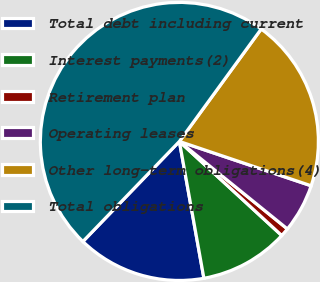Convert chart. <chart><loc_0><loc_0><loc_500><loc_500><pie_chart><fcel>Total debt including current<fcel>Interest payments(2)<fcel>Retirement plan<fcel>Operating leases<fcel>Other long-term obligations(4)<fcel>Total obligations<nl><fcel>15.03%<fcel>10.35%<fcel>0.99%<fcel>5.67%<fcel>20.15%<fcel>47.8%<nl></chart> 